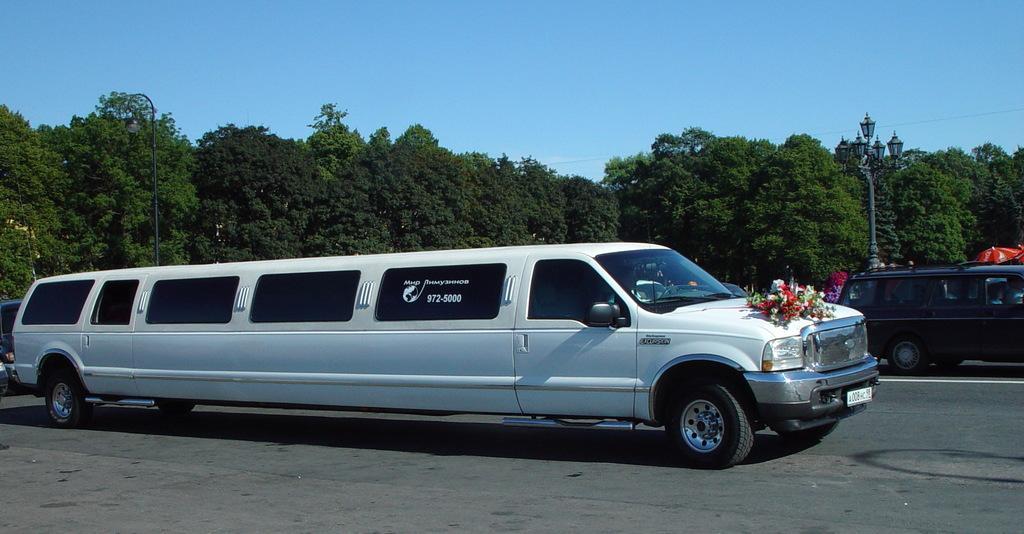Describe this image in one or two sentences. In this picture we can see some vehicles parked on the path. Behind the vehicles there are poles with light and behind the poles there are trees and the sky. On the white car there are flowers. 